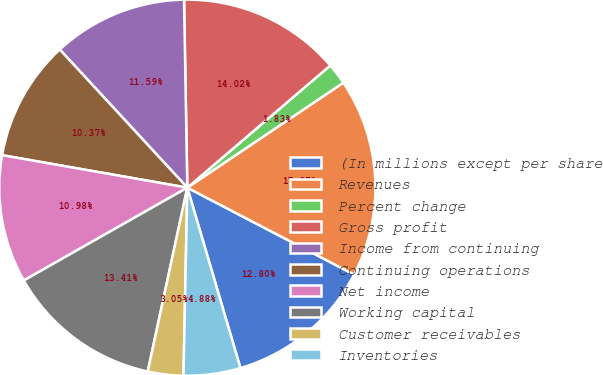<chart> <loc_0><loc_0><loc_500><loc_500><pie_chart><fcel>(In millions except per share<fcel>Revenues<fcel>Percent change<fcel>Gross profit<fcel>Income from continuing<fcel>Continuing operations<fcel>Net income<fcel>Working capital<fcel>Customer receivables<fcel>Inventories<nl><fcel>12.8%<fcel>17.07%<fcel>1.83%<fcel>14.02%<fcel>11.59%<fcel>10.37%<fcel>10.98%<fcel>13.41%<fcel>3.05%<fcel>4.88%<nl></chart> 